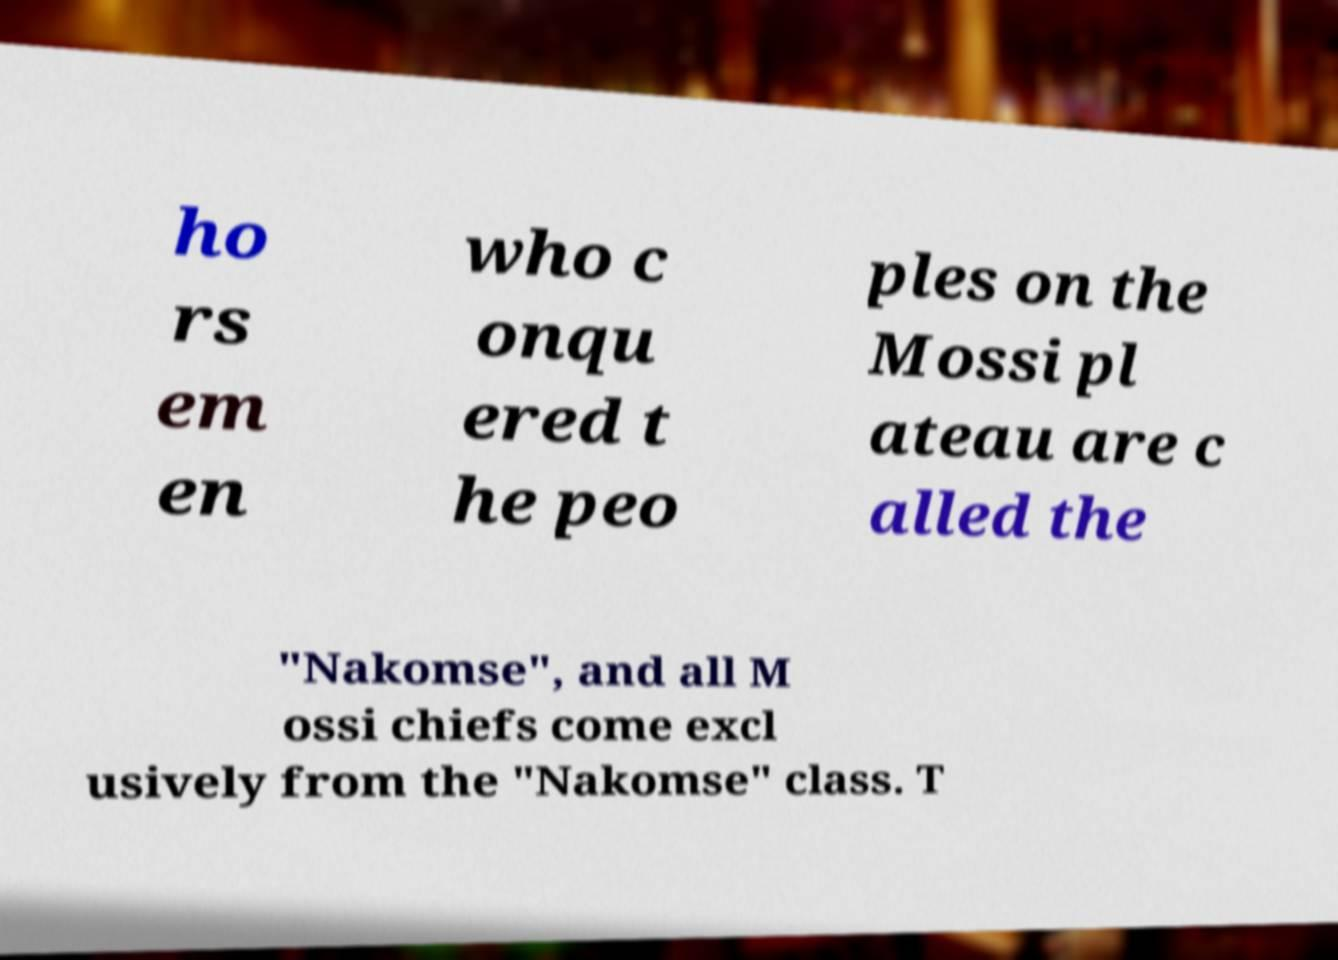Can you read and provide the text displayed in the image?This photo seems to have some interesting text. Can you extract and type it out for me? ho rs em en who c onqu ered t he peo ples on the Mossi pl ateau are c alled the "Nakomse", and all M ossi chiefs come excl usively from the "Nakomse" class. T 